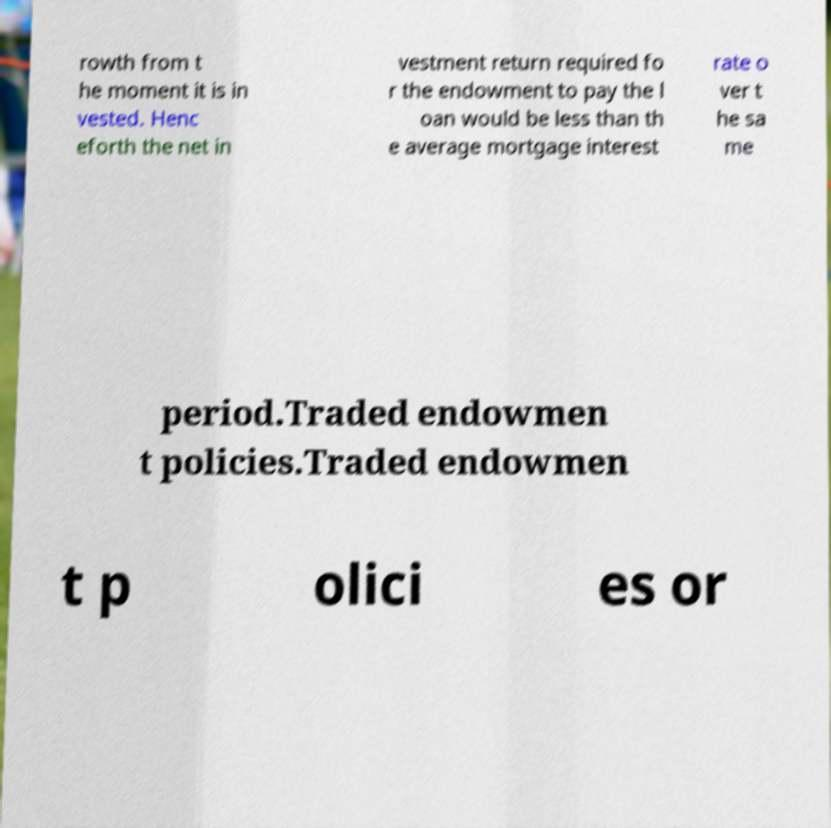For documentation purposes, I need the text within this image transcribed. Could you provide that? rowth from t he moment it is in vested. Henc eforth the net in vestment return required fo r the endowment to pay the l oan would be less than th e average mortgage interest rate o ver t he sa me period.Traded endowmen t policies.Traded endowmen t p olici es or 